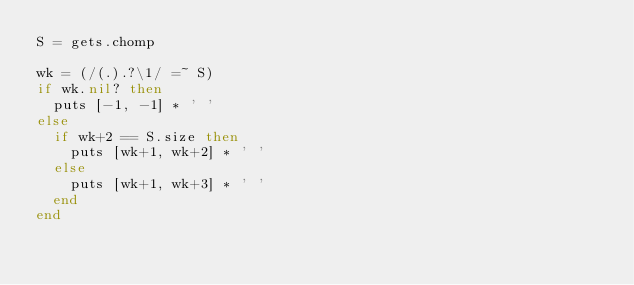<code> <loc_0><loc_0><loc_500><loc_500><_Ruby_>S = gets.chomp

wk = (/(.).?\1/ =~ S)
if wk.nil? then
  puts [-1, -1] * ' '
else
  if wk+2 == S.size then
    puts [wk+1, wk+2] * ' '
  else
    puts [wk+1, wk+3] * ' '
  end
end
</code> 